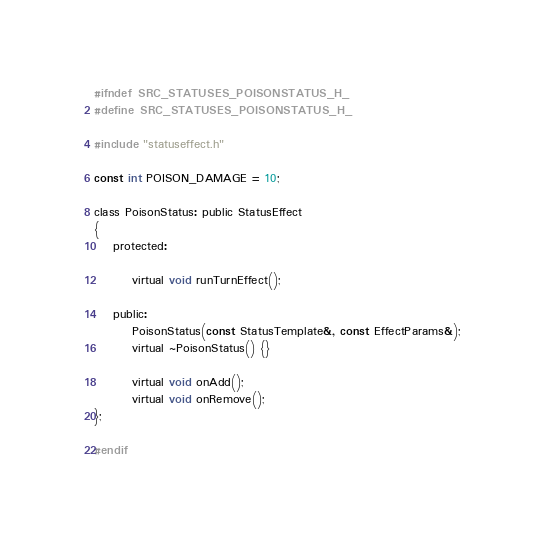Convert code to text. <code><loc_0><loc_0><loc_500><loc_500><_C_>#ifndef SRC_STATUSES_POISONSTATUS_H_
#define SRC_STATUSES_POISONSTATUS_H_

#include "statuseffect.h"

const int POISON_DAMAGE = 10;

class PoisonStatus: public StatusEffect
{
	protected:

		virtual void runTurnEffect();

	public:
		PoisonStatus(const StatusTemplate&, const EffectParams&);
		virtual ~PoisonStatus() {}

		virtual void onAdd();
		virtual void onRemove();
};

#endif
</code> 